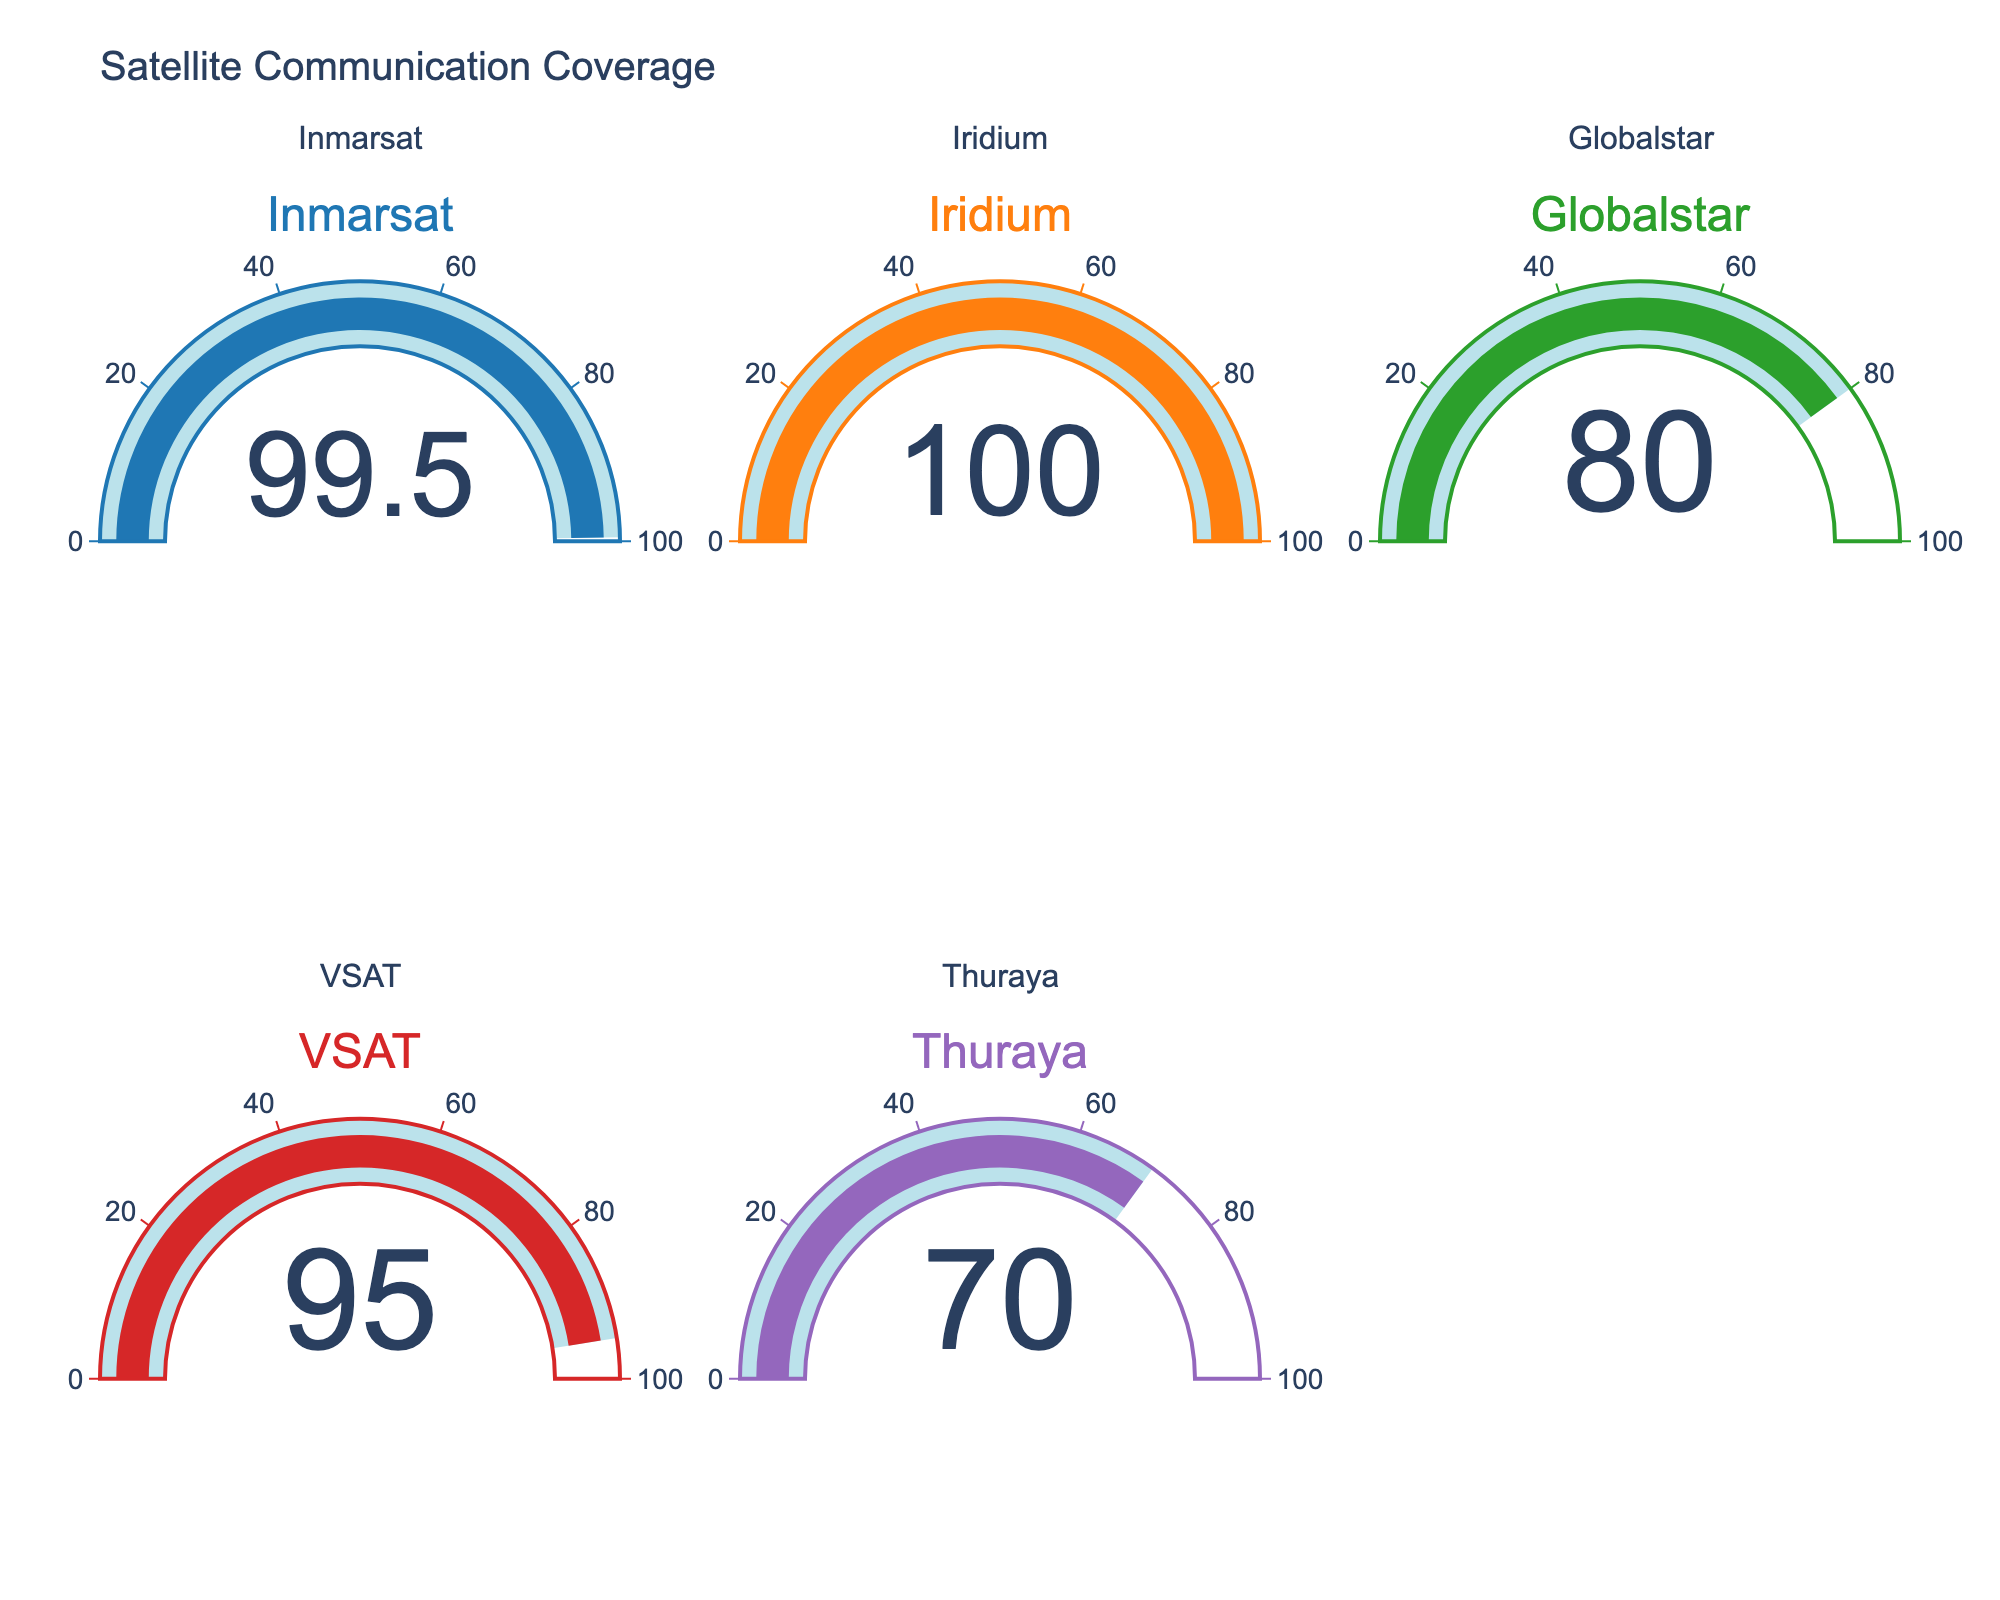What's the title of the figure? The title of the figure is displayed at the top and reads "Satellite Communication Coverage".
Answer: Satellite Communication Coverage How many satellites are displayed in the figure? By counting the gauges, we see there are five different satellites displayed in the figure.
Answer: Five Which satellite has the highest coverage percentage? By looking at the gauges, the satellite with the highest value is "Iridium," showing 100%.
Answer: Iridium Which satellite has the lowest coverage percentage? By observing the gauges, the satellite with the lowest value is "Thuraya," showing 70%.
Answer: Thuraya What is the average coverage percentage of all the satellites? Sum the coverage percentages: 99.5 (Inmarsat) + 100 (Iridium) + 80 (Globalstar) + 95 (VSAT) + 70 (Thuraya) = 444.5. Then, divide by the number of satellites, 5: 444.5 / 5 = 89.
Answer: 89 How many satellites have coverage above 90%? Identify the satellites with coverage values above 90%: Inmarsat (99.5), Iridium (100), and VSAT (95). So, there are three satellites.
Answer: Three What is the difference in coverage percentage between Globalstar and Iridium? Subtract the coverage of Globalstar from Iridium: 100 (Iridium) - 80 (Globalstar) = 20.
Answer: 20 Is there any satellite with exactly 100% coverage? By examining the gauges, it is clear that "Iridium" has a coverage percentage of exactly 100%.
Answer: Yes Which satellites have a coverage percentage below 90%? By checking each gauge, the satellites with coverage below 90% are Globalstar (80) and Thuraya (70).
Answer: Globalstar and Thuraya 